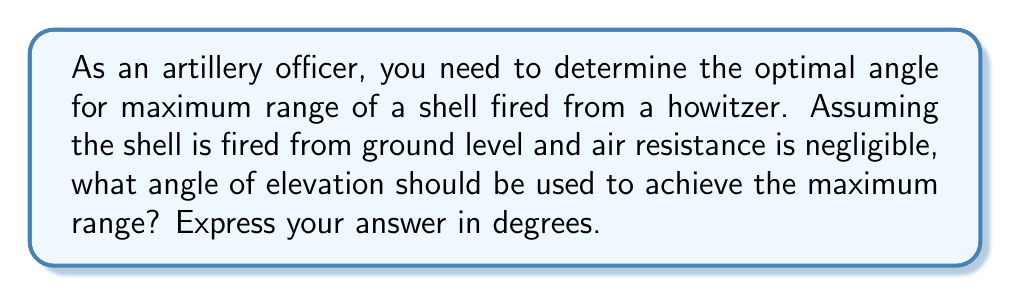Can you solve this math problem? To solve this problem, we need to consider the principles of projectile motion. In the absence of air resistance, the trajectory of the shell follows a parabolic path.

The range of a projectile is given by the formula:

$$R = \frac{v_0^2 \sin(2\theta)}{g}$$

Where:
$R$ = range
$v_0$ = initial velocity
$\theta$ = angle of elevation
$g$ = acceleration due to gravity

To find the maximum range, we need to maximize $\sin(2\theta)$. The sine function reaches its maximum value of 1 when its argument is 90°.

Therefore:

$$2\theta = 90°$$
$$\theta = 45°$$

This result can also be derived using calculus by taking the derivative of the range equation with respect to $\theta$, setting it to zero, and solving for $\theta$.

The physical interpretation of this result is that at 45°, there is an optimal balance between the horizontal and vertical components of the shell's velocity. Any angle smaller than 45° will result in the shell traveling too low and hitting the ground too soon, while any angle larger than 45° will result in the shell traveling too high and not utilizing its full horizontal potential.

It's important to note that this result assumes ideal conditions. In real-world scenarios, factors such as air resistance, wind, and the curvature of the Earth can affect the optimal angle, often making it slightly less than 45°.
Answer: 45° 